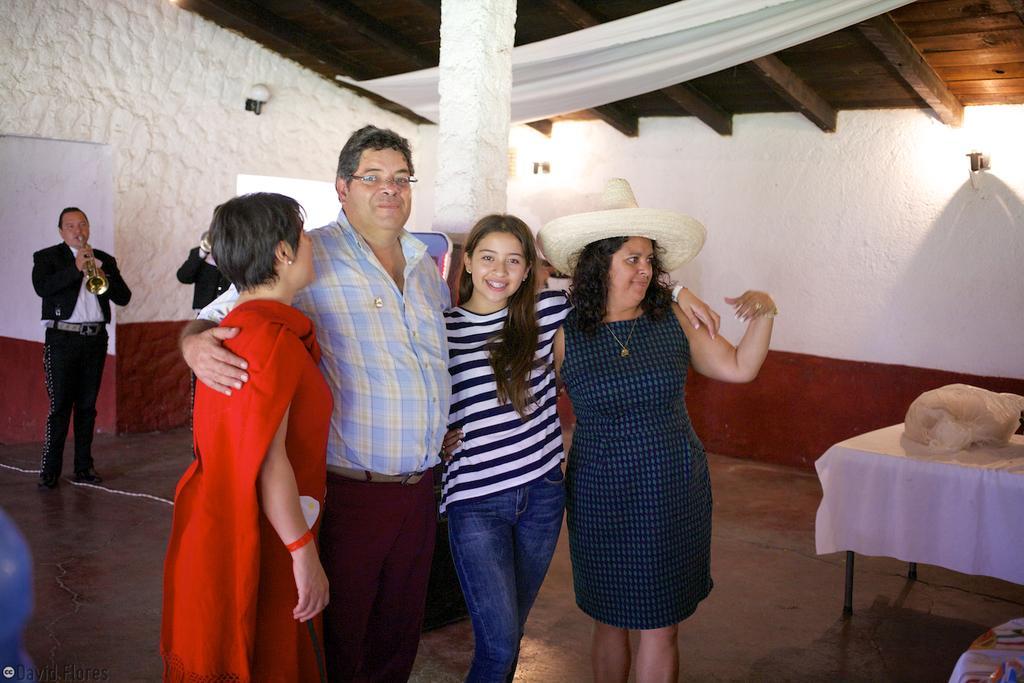Describe this image in one or two sentences. This picture is clicked inside the room. In the center we can see a person wearing shirt and standing and we can see a person wearing t-shirt, smiling and standing and we can see a woman wearing blue color frock, hat and standing and we can see another woman wearing red color dress and standing and we can see there are some objects and we can see an object is placed on the top of the table. In the background we can see the wall mounted lamps, pillar, group of persons playing trumpets and standing on the floor. At the top there is a roof and a white color object seems to be the curtain. In the bottom left corner we can see the watermark on the image. 